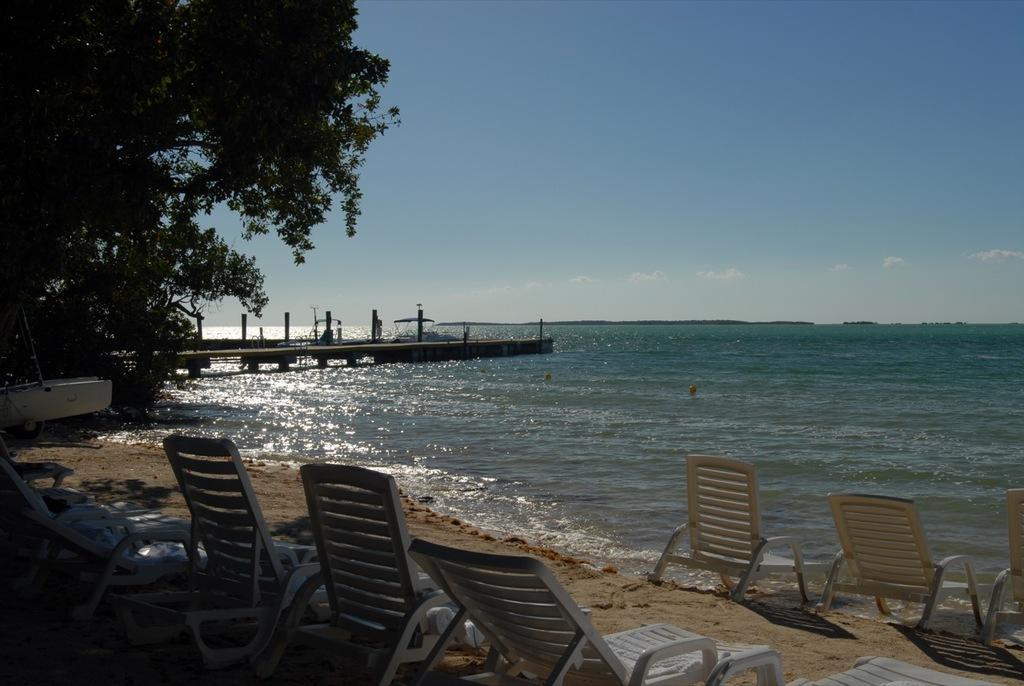Please provide a concise description of this image. In this image I can see some beach beds on the sand. To the side of the beach beds I can see the water and the trees. I can see the wooden bridge on the water. In the background I can see the sky. 